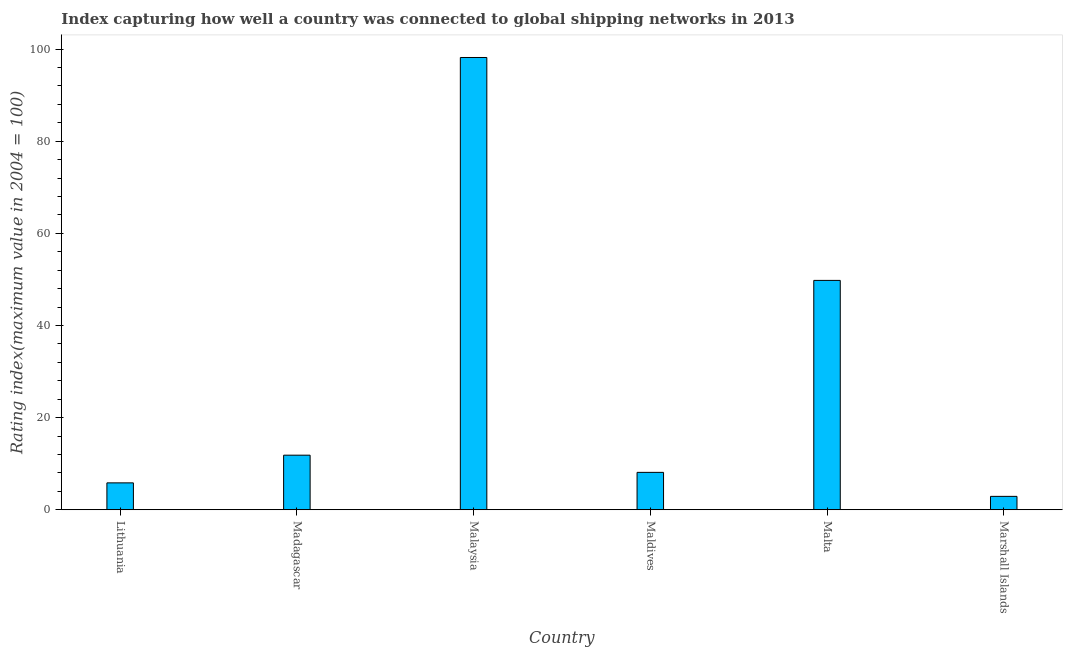Does the graph contain grids?
Your answer should be very brief. No. What is the title of the graph?
Your answer should be very brief. Index capturing how well a country was connected to global shipping networks in 2013. What is the label or title of the X-axis?
Your answer should be compact. Country. What is the label or title of the Y-axis?
Offer a very short reply. Rating index(maximum value in 2004 = 100). What is the liner shipping connectivity index in Madagascar?
Offer a terse response. 11.85. Across all countries, what is the maximum liner shipping connectivity index?
Give a very brief answer. 98.18. Across all countries, what is the minimum liner shipping connectivity index?
Keep it short and to the point. 2.91. In which country was the liner shipping connectivity index maximum?
Your answer should be compact. Malaysia. In which country was the liner shipping connectivity index minimum?
Keep it short and to the point. Marshall Islands. What is the sum of the liner shipping connectivity index?
Give a very brief answer. 176.69. What is the difference between the liner shipping connectivity index in Malta and Marshall Islands?
Your answer should be very brief. 46.88. What is the average liner shipping connectivity index per country?
Ensure brevity in your answer.  29.45. What is the median liner shipping connectivity index?
Keep it short and to the point. 9.98. In how many countries, is the liner shipping connectivity index greater than 36 ?
Offer a terse response. 2. What is the ratio of the liner shipping connectivity index in Malaysia to that in Malta?
Give a very brief answer. 1.97. What is the difference between the highest and the second highest liner shipping connectivity index?
Offer a terse response. 48.39. Is the sum of the liner shipping connectivity index in Maldives and Malta greater than the maximum liner shipping connectivity index across all countries?
Give a very brief answer. No. What is the difference between the highest and the lowest liner shipping connectivity index?
Your answer should be compact. 95.27. How many countries are there in the graph?
Offer a terse response. 6. What is the Rating index(maximum value in 2004 = 100) of Lithuania?
Provide a succinct answer. 5.84. What is the Rating index(maximum value in 2004 = 100) of Madagascar?
Your answer should be compact. 11.85. What is the Rating index(maximum value in 2004 = 100) in Malaysia?
Offer a terse response. 98.18. What is the Rating index(maximum value in 2004 = 100) of Maldives?
Provide a short and direct response. 8.12. What is the Rating index(maximum value in 2004 = 100) of Malta?
Make the answer very short. 49.79. What is the Rating index(maximum value in 2004 = 100) of Marshall Islands?
Give a very brief answer. 2.91. What is the difference between the Rating index(maximum value in 2004 = 100) in Lithuania and Madagascar?
Offer a terse response. -6.01. What is the difference between the Rating index(maximum value in 2004 = 100) in Lithuania and Malaysia?
Provide a succinct answer. -92.34. What is the difference between the Rating index(maximum value in 2004 = 100) in Lithuania and Maldives?
Keep it short and to the point. -2.28. What is the difference between the Rating index(maximum value in 2004 = 100) in Lithuania and Malta?
Provide a succinct answer. -43.95. What is the difference between the Rating index(maximum value in 2004 = 100) in Lithuania and Marshall Islands?
Your response must be concise. 2.93. What is the difference between the Rating index(maximum value in 2004 = 100) in Madagascar and Malaysia?
Your answer should be very brief. -86.33. What is the difference between the Rating index(maximum value in 2004 = 100) in Madagascar and Maldives?
Make the answer very short. 3.73. What is the difference between the Rating index(maximum value in 2004 = 100) in Madagascar and Malta?
Provide a succinct answer. -37.94. What is the difference between the Rating index(maximum value in 2004 = 100) in Madagascar and Marshall Islands?
Give a very brief answer. 8.94. What is the difference between the Rating index(maximum value in 2004 = 100) in Malaysia and Maldives?
Your response must be concise. 90.06. What is the difference between the Rating index(maximum value in 2004 = 100) in Malaysia and Malta?
Keep it short and to the point. 48.39. What is the difference between the Rating index(maximum value in 2004 = 100) in Malaysia and Marshall Islands?
Provide a short and direct response. 95.27. What is the difference between the Rating index(maximum value in 2004 = 100) in Maldives and Malta?
Keep it short and to the point. -41.67. What is the difference between the Rating index(maximum value in 2004 = 100) in Maldives and Marshall Islands?
Keep it short and to the point. 5.21. What is the difference between the Rating index(maximum value in 2004 = 100) in Malta and Marshall Islands?
Your answer should be compact. 46.88. What is the ratio of the Rating index(maximum value in 2004 = 100) in Lithuania to that in Madagascar?
Give a very brief answer. 0.49. What is the ratio of the Rating index(maximum value in 2004 = 100) in Lithuania to that in Malaysia?
Give a very brief answer. 0.06. What is the ratio of the Rating index(maximum value in 2004 = 100) in Lithuania to that in Maldives?
Keep it short and to the point. 0.72. What is the ratio of the Rating index(maximum value in 2004 = 100) in Lithuania to that in Malta?
Offer a very short reply. 0.12. What is the ratio of the Rating index(maximum value in 2004 = 100) in Lithuania to that in Marshall Islands?
Your answer should be compact. 2.01. What is the ratio of the Rating index(maximum value in 2004 = 100) in Madagascar to that in Malaysia?
Offer a very short reply. 0.12. What is the ratio of the Rating index(maximum value in 2004 = 100) in Madagascar to that in Maldives?
Ensure brevity in your answer.  1.46. What is the ratio of the Rating index(maximum value in 2004 = 100) in Madagascar to that in Malta?
Your answer should be very brief. 0.24. What is the ratio of the Rating index(maximum value in 2004 = 100) in Madagascar to that in Marshall Islands?
Keep it short and to the point. 4.07. What is the ratio of the Rating index(maximum value in 2004 = 100) in Malaysia to that in Maldives?
Your response must be concise. 12.09. What is the ratio of the Rating index(maximum value in 2004 = 100) in Malaysia to that in Malta?
Provide a succinct answer. 1.97. What is the ratio of the Rating index(maximum value in 2004 = 100) in Malaysia to that in Marshall Islands?
Provide a succinct answer. 33.74. What is the ratio of the Rating index(maximum value in 2004 = 100) in Maldives to that in Malta?
Make the answer very short. 0.16. What is the ratio of the Rating index(maximum value in 2004 = 100) in Maldives to that in Marshall Islands?
Ensure brevity in your answer.  2.79. What is the ratio of the Rating index(maximum value in 2004 = 100) in Malta to that in Marshall Islands?
Your answer should be very brief. 17.11. 